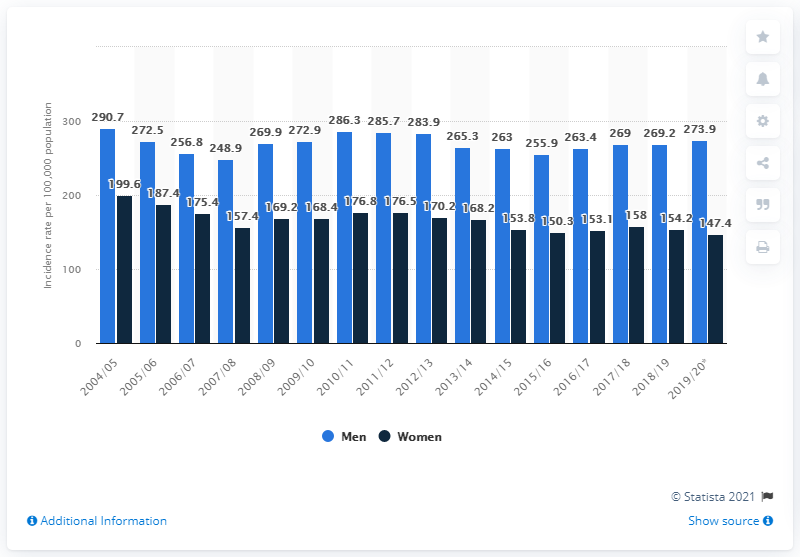Identify some key points in this picture. In 2019/20, the incidence rate for men in Scotland was 273.9 per 100,000 population. In the year 2019/2020, the incidence rate for women in Scotland was 147.4 per 100,000 population. 